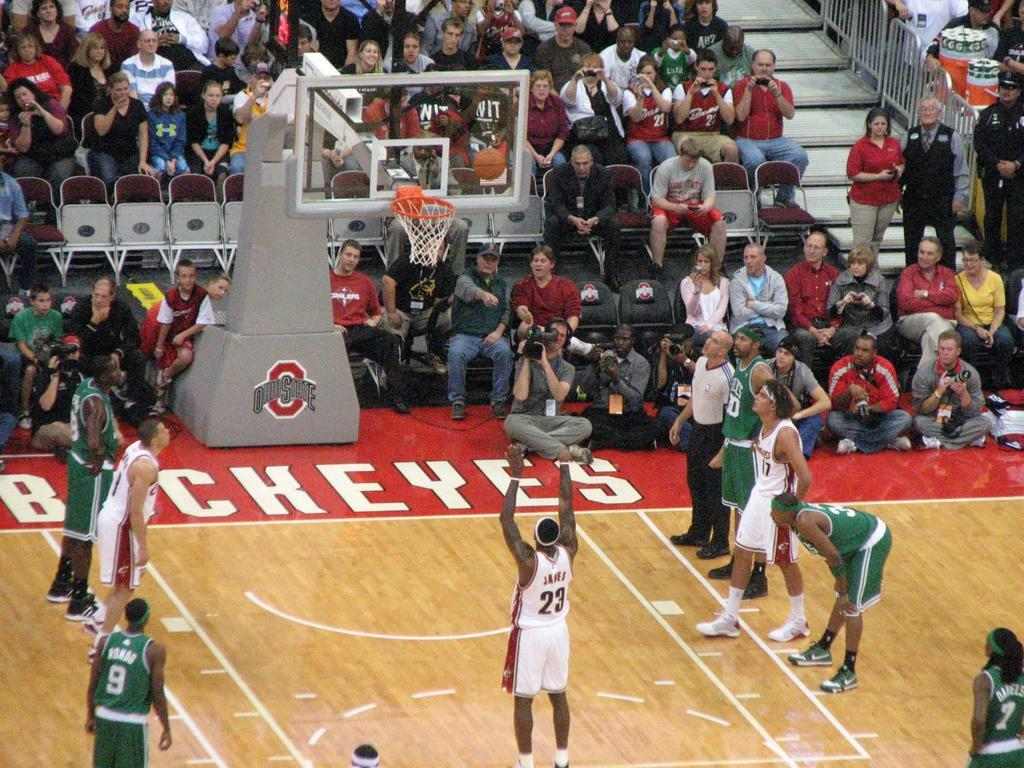<image>
Give a short and clear explanation of the subsequent image. a basketball court with number 23 at the freethrow line 